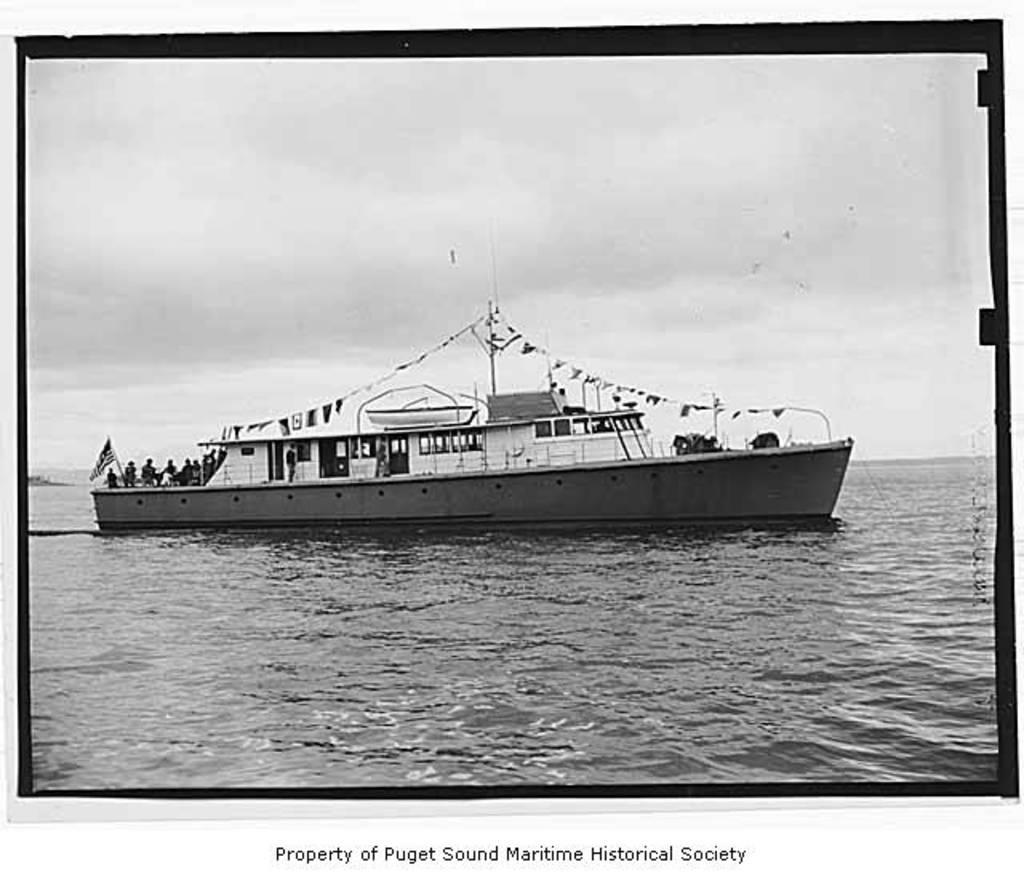<image>
Share a concise interpretation of the image provided. An old cruise ship is sailing in the ocean and its labeled Property of Puget Sound Maritime Historical Society. 